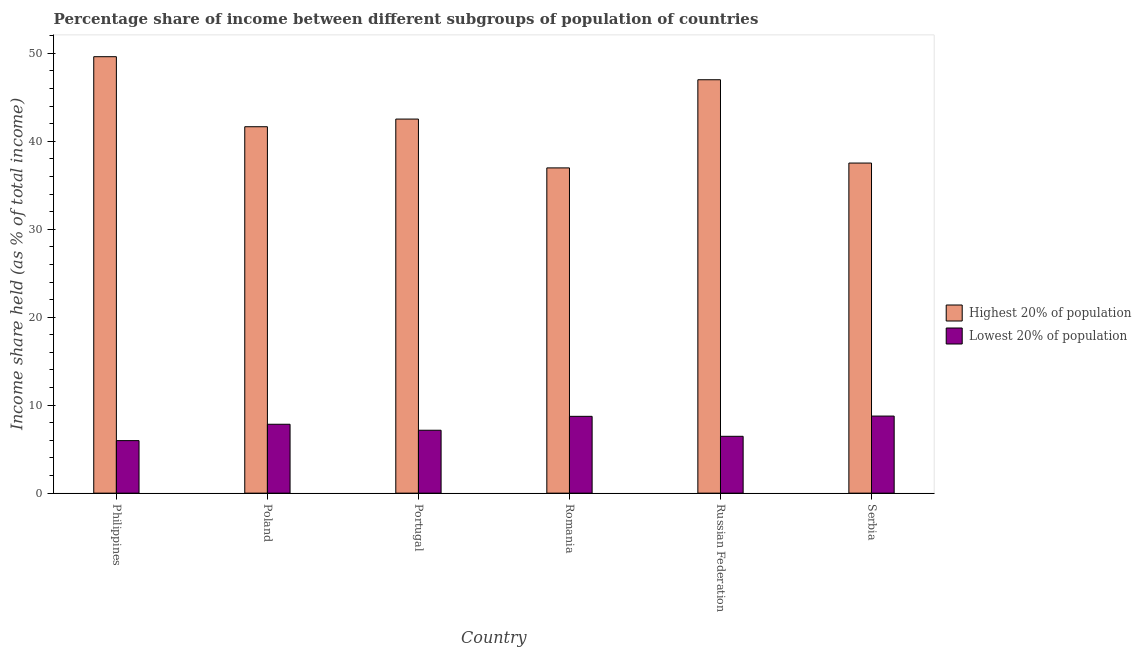How many different coloured bars are there?
Keep it short and to the point. 2. How many groups of bars are there?
Your answer should be compact. 6. Are the number of bars on each tick of the X-axis equal?
Your answer should be very brief. Yes. How many bars are there on the 4th tick from the left?
Give a very brief answer. 2. What is the label of the 1st group of bars from the left?
Provide a short and direct response. Philippines. In how many cases, is the number of bars for a given country not equal to the number of legend labels?
Your answer should be compact. 0. What is the income share held by lowest 20% of the population in Poland?
Offer a terse response. 7.83. Across all countries, what is the maximum income share held by lowest 20% of the population?
Give a very brief answer. 8.76. Across all countries, what is the minimum income share held by highest 20% of the population?
Keep it short and to the point. 36.97. In which country was the income share held by highest 20% of the population minimum?
Offer a terse response. Romania. What is the total income share held by lowest 20% of the population in the graph?
Make the answer very short. 44.9. What is the difference between the income share held by lowest 20% of the population in Philippines and that in Russian Federation?
Give a very brief answer. -0.49. What is the difference between the income share held by lowest 20% of the population in Philippines and the income share held by highest 20% of the population in Romania?
Offer a very short reply. -31. What is the average income share held by highest 20% of the population per country?
Make the answer very short. 42.54. What is the difference between the income share held by highest 20% of the population and income share held by lowest 20% of the population in Portugal?
Give a very brief answer. 35.37. In how many countries, is the income share held by highest 20% of the population greater than 48 %?
Provide a short and direct response. 1. What is the ratio of the income share held by highest 20% of the population in Russian Federation to that in Serbia?
Your answer should be compact. 1.25. What is the difference between the highest and the second highest income share held by highest 20% of the population?
Your response must be concise. 2.62. What is the difference between the highest and the lowest income share held by lowest 20% of the population?
Provide a short and direct response. 2.79. In how many countries, is the income share held by lowest 20% of the population greater than the average income share held by lowest 20% of the population taken over all countries?
Provide a succinct answer. 3. Is the sum of the income share held by highest 20% of the population in Philippines and Russian Federation greater than the maximum income share held by lowest 20% of the population across all countries?
Your answer should be very brief. Yes. What does the 2nd bar from the left in Russian Federation represents?
Provide a short and direct response. Lowest 20% of population. What does the 2nd bar from the right in Russian Federation represents?
Make the answer very short. Highest 20% of population. How many countries are there in the graph?
Your answer should be very brief. 6. How many legend labels are there?
Keep it short and to the point. 2. What is the title of the graph?
Offer a terse response. Percentage share of income between different subgroups of population of countries. Does "Non-resident workers" appear as one of the legend labels in the graph?
Keep it short and to the point. No. What is the label or title of the Y-axis?
Keep it short and to the point. Income share held (as % of total income). What is the Income share held (as % of total income) in Highest 20% of population in Philippines?
Keep it short and to the point. 49.61. What is the Income share held (as % of total income) in Lowest 20% of population in Philippines?
Your answer should be very brief. 5.97. What is the Income share held (as % of total income) in Highest 20% of population in Poland?
Your answer should be very brief. 41.65. What is the Income share held (as % of total income) in Lowest 20% of population in Poland?
Ensure brevity in your answer.  7.83. What is the Income share held (as % of total income) of Highest 20% of population in Portugal?
Your answer should be compact. 42.52. What is the Income share held (as % of total income) of Lowest 20% of population in Portugal?
Your answer should be very brief. 7.15. What is the Income share held (as % of total income) in Highest 20% of population in Romania?
Make the answer very short. 36.97. What is the Income share held (as % of total income) of Lowest 20% of population in Romania?
Keep it short and to the point. 8.73. What is the Income share held (as % of total income) of Highest 20% of population in Russian Federation?
Offer a very short reply. 46.99. What is the Income share held (as % of total income) in Lowest 20% of population in Russian Federation?
Your answer should be very brief. 6.46. What is the Income share held (as % of total income) in Highest 20% of population in Serbia?
Give a very brief answer. 37.52. What is the Income share held (as % of total income) of Lowest 20% of population in Serbia?
Keep it short and to the point. 8.76. Across all countries, what is the maximum Income share held (as % of total income) of Highest 20% of population?
Make the answer very short. 49.61. Across all countries, what is the maximum Income share held (as % of total income) in Lowest 20% of population?
Keep it short and to the point. 8.76. Across all countries, what is the minimum Income share held (as % of total income) of Highest 20% of population?
Offer a very short reply. 36.97. Across all countries, what is the minimum Income share held (as % of total income) of Lowest 20% of population?
Your answer should be compact. 5.97. What is the total Income share held (as % of total income) of Highest 20% of population in the graph?
Your response must be concise. 255.26. What is the total Income share held (as % of total income) in Lowest 20% of population in the graph?
Give a very brief answer. 44.9. What is the difference between the Income share held (as % of total income) in Highest 20% of population in Philippines and that in Poland?
Your answer should be very brief. 7.96. What is the difference between the Income share held (as % of total income) of Lowest 20% of population in Philippines and that in Poland?
Offer a very short reply. -1.86. What is the difference between the Income share held (as % of total income) in Highest 20% of population in Philippines and that in Portugal?
Keep it short and to the point. 7.09. What is the difference between the Income share held (as % of total income) in Lowest 20% of population in Philippines and that in Portugal?
Your answer should be compact. -1.18. What is the difference between the Income share held (as % of total income) in Highest 20% of population in Philippines and that in Romania?
Ensure brevity in your answer.  12.64. What is the difference between the Income share held (as % of total income) in Lowest 20% of population in Philippines and that in Romania?
Provide a succinct answer. -2.76. What is the difference between the Income share held (as % of total income) in Highest 20% of population in Philippines and that in Russian Federation?
Give a very brief answer. 2.62. What is the difference between the Income share held (as % of total income) in Lowest 20% of population in Philippines and that in Russian Federation?
Your response must be concise. -0.49. What is the difference between the Income share held (as % of total income) in Highest 20% of population in Philippines and that in Serbia?
Give a very brief answer. 12.09. What is the difference between the Income share held (as % of total income) in Lowest 20% of population in Philippines and that in Serbia?
Give a very brief answer. -2.79. What is the difference between the Income share held (as % of total income) of Highest 20% of population in Poland and that in Portugal?
Offer a terse response. -0.87. What is the difference between the Income share held (as % of total income) of Lowest 20% of population in Poland and that in Portugal?
Your response must be concise. 0.68. What is the difference between the Income share held (as % of total income) of Highest 20% of population in Poland and that in Romania?
Offer a very short reply. 4.68. What is the difference between the Income share held (as % of total income) of Highest 20% of population in Poland and that in Russian Federation?
Your answer should be very brief. -5.34. What is the difference between the Income share held (as % of total income) of Lowest 20% of population in Poland and that in Russian Federation?
Offer a terse response. 1.37. What is the difference between the Income share held (as % of total income) in Highest 20% of population in Poland and that in Serbia?
Keep it short and to the point. 4.13. What is the difference between the Income share held (as % of total income) of Lowest 20% of population in Poland and that in Serbia?
Provide a short and direct response. -0.93. What is the difference between the Income share held (as % of total income) in Highest 20% of population in Portugal and that in Romania?
Make the answer very short. 5.55. What is the difference between the Income share held (as % of total income) in Lowest 20% of population in Portugal and that in Romania?
Provide a short and direct response. -1.58. What is the difference between the Income share held (as % of total income) in Highest 20% of population in Portugal and that in Russian Federation?
Ensure brevity in your answer.  -4.47. What is the difference between the Income share held (as % of total income) of Lowest 20% of population in Portugal and that in Russian Federation?
Offer a terse response. 0.69. What is the difference between the Income share held (as % of total income) in Lowest 20% of population in Portugal and that in Serbia?
Provide a succinct answer. -1.61. What is the difference between the Income share held (as % of total income) in Highest 20% of population in Romania and that in Russian Federation?
Your answer should be compact. -10.02. What is the difference between the Income share held (as % of total income) of Lowest 20% of population in Romania and that in Russian Federation?
Your answer should be very brief. 2.27. What is the difference between the Income share held (as % of total income) in Highest 20% of population in Romania and that in Serbia?
Provide a succinct answer. -0.55. What is the difference between the Income share held (as % of total income) of Lowest 20% of population in Romania and that in Serbia?
Give a very brief answer. -0.03. What is the difference between the Income share held (as % of total income) in Highest 20% of population in Russian Federation and that in Serbia?
Provide a short and direct response. 9.47. What is the difference between the Income share held (as % of total income) in Lowest 20% of population in Russian Federation and that in Serbia?
Your answer should be very brief. -2.3. What is the difference between the Income share held (as % of total income) of Highest 20% of population in Philippines and the Income share held (as % of total income) of Lowest 20% of population in Poland?
Your response must be concise. 41.78. What is the difference between the Income share held (as % of total income) in Highest 20% of population in Philippines and the Income share held (as % of total income) in Lowest 20% of population in Portugal?
Provide a short and direct response. 42.46. What is the difference between the Income share held (as % of total income) of Highest 20% of population in Philippines and the Income share held (as % of total income) of Lowest 20% of population in Romania?
Offer a terse response. 40.88. What is the difference between the Income share held (as % of total income) in Highest 20% of population in Philippines and the Income share held (as % of total income) in Lowest 20% of population in Russian Federation?
Ensure brevity in your answer.  43.15. What is the difference between the Income share held (as % of total income) of Highest 20% of population in Philippines and the Income share held (as % of total income) of Lowest 20% of population in Serbia?
Provide a succinct answer. 40.85. What is the difference between the Income share held (as % of total income) in Highest 20% of population in Poland and the Income share held (as % of total income) in Lowest 20% of population in Portugal?
Keep it short and to the point. 34.5. What is the difference between the Income share held (as % of total income) in Highest 20% of population in Poland and the Income share held (as % of total income) in Lowest 20% of population in Romania?
Ensure brevity in your answer.  32.92. What is the difference between the Income share held (as % of total income) in Highest 20% of population in Poland and the Income share held (as % of total income) in Lowest 20% of population in Russian Federation?
Your answer should be very brief. 35.19. What is the difference between the Income share held (as % of total income) of Highest 20% of population in Poland and the Income share held (as % of total income) of Lowest 20% of population in Serbia?
Your answer should be compact. 32.89. What is the difference between the Income share held (as % of total income) of Highest 20% of population in Portugal and the Income share held (as % of total income) of Lowest 20% of population in Romania?
Your answer should be very brief. 33.79. What is the difference between the Income share held (as % of total income) in Highest 20% of population in Portugal and the Income share held (as % of total income) in Lowest 20% of population in Russian Federation?
Your response must be concise. 36.06. What is the difference between the Income share held (as % of total income) of Highest 20% of population in Portugal and the Income share held (as % of total income) of Lowest 20% of population in Serbia?
Offer a very short reply. 33.76. What is the difference between the Income share held (as % of total income) in Highest 20% of population in Romania and the Income share held (as % of total income) in Lowest 20% of population in Russian Federation?
Offer a very short reply. 30.51. What is the difference between the Income share held (as % of total income) of Highest 20% of population in Romania and the Income share held (as % of total income) of Lowest 20% of population in Serbia?
Give a very brief answer. 28.21. What is the difference between the Income share held (as % of total income) of Highest 20% of population in Russian Federation and the Income share held (as % of total income) of Lowest 20% of population in Serbia?
Provide a succinct answer. 38.23. What is the average Income share held (as % of total income) in Highest 20% of population per country?
Your answer should be compact. 42.54. What is the average Income share held (as % of total income) in Lowest 20% of population per country?
Your answer should be very brief. 7.48. What is the difference between the Income share held (as % of total income) of Highest 20% of population and Income share held (as % of total income) of Lowest 20% of population in Philippines?
Offer a terse response. 43.64. What is the difference between the Income share held (as % of total income) in Highest 20% of population and Income share held (as % of total income) in Lowest 20% of population in Poland?
Offer a very short reply. 33.82. What is the difference between the Income share held (as % of total income) in Highest 20% of population and Income share held (as % of total income) in Lowest 20% of population in Portugal?
Give a very brief answer. 35.37. What is the difference between the Income share held (as % of total income) in Highest 20% of population and Income share held (as % of total income) in Lowest 20% of population in Romania?
Keep it short and to the point. 28.24. What is the difference between the Income share held (as % of total income) in Highest 20% of population and Income share held (as % of total income) in Lowest 20% of population in Russian Federation?
Your answer should be very brief. 40.53. What is the difference between the Income share held (as % of total income) of Highest 20% of population and Income share held (as % of total income) of Lowest 20% of population in Serbia?
Keep it short and to the point. 28.76. What is the ratio of the Income share held (as % of total income) in Highest 20% of population in Philippines to that in Poland?
Offer a terse response. 1.19. What is the ratio of the Income share held (as % of total income) of Lowest 20% of population in Philippines to that in Poland?
Make the answer very short. 0.76. What is the ratio of the Income share held (as % of total income) of Highest 20% of population in Philippines to that in Portugal?
Ensure brevity in your answer.  1.17. What is the ratio of the Income share held (as % of total income) in Lowest 20% of population in Philippines to that in Portugal?
Offer a terse response. 0.83. What is the ratio of the Income share held (as % of total income) of Highest 20% of population in Philippines to that in Romania?
Your answer should be compact. 1.34. What is the ratio of the Income share held (as % of total income) of Lowest 20% of population in Philippines to that in Romania?
Your answer should be compact. 0.68. What is the ratio of the Income share held (as % of total income) of Highest 20% of population in Philippines to that in Russian Federation?
Ensure brevity in your answer.  1.06. What is the ratio of the Income share held (as % of total income) in Lowest 20% of population in Philippines to that in Russian Federation?
Give a very brief answer. 0.92. What is the ratio of the Income share held (as % of total income) of Highest 20% of population in Philippines to that in Serbia?
Provide a succinct answer. 1.32. What is the ratio of the Income share held (as % of total income) of Lowest 20% of population in Philippines to that in Serbia?
Provide a succinct answer. 0.68. What is the ratio of the Income share held (as % of total income) of Highest 20% of population in Poland to that in Portugal?
Your response must be concise. 0.98. What is the ratio of the Income share held (as % of total income) of Lowest 20% of population in Poland to that in Portugal?
Keep it short and to the point. 1.1. What is the ratio of the Income share held (as % of total income) in Highest 20% of population in Poland to that in Romania?
Your response must be concise. 1.13. What is the ratio of the Income share held (as % of total income) in Lowest 20% of population in Poland to that in Romania?
Give a very brief answer. 0.9. What is the ratio of the Income share held (as % of total income) in Highest 20% of population in Poland to that in Russian Federation?
Offer a terse response. 0.89. What is the ratio of the Income share held (as % of total income) of Lowest 20% of population in Poland to that in Russian Federation?
Your response must be concise. 1.21. What is the ratio of the Income share held (as % of total income) of Highest 20% of population in Poland to that in Serbia?
Give a very brief answer. 1.11. What is the ratio of the Income share held (as % of total income) of Lowest 20% of population in Poland to that in Serbia?
Offer a very short reply. 0.89. What is the ratio of the Income share held (as % of total income) in Highest 20% of population in Portugal to that in Romania?
Your answer should be very brief. 1.15. What is the ratio of the Income share held (as % of total income) of Lowest 20% of population in Portugal to that in Romania?
Provide a short and direct response. 0.82. What is the ratio of the Income share held (as % of total income) in Highest 20% of population in Portugal to that in Russian Federation?
Your answer should be very brief. 0.9. What is the ratio of the Income share held (as % of total income) in Lowest 20% of population in Portugal to that in Russian Federation?
Keep it short and to the point. 1.11. What is the ratio of the Income share held (as % of total income) of Highest 20% of population in Portugal to that in Serbia?
Make the answer very short. 1.13. What is the ratio of the Income share held (as % of total income) in Lowest 20% of population in Portugal to that in Serbia?
Give a very brief answer. 0.82. What is the ratio of the Income share held (as % of total income) in Highest 20% of population in Romania to that in Russian Federation?
Ensure brevity in your answer.  0.79. What is the ratio of the Income share held (as % of total income) of Lowest 20% of population in Romania to that in Russian Federation?
Offer a very short reply. 1.35. What is the ratio of the Income share held (as % of total income) of Highest 20% of population in Romania to that in Serbia?
Your answer should be compact. 0.99. What is the ratio of the Income share held (as % of total income) of Lowest 20% of population in Romania to that in Serbia?
Your response must be concise. 1. What is the ratio of the Income share held (as % of total income) of Highest 20% of population in Russian Federation to that in Serbia?
Give a very brief answer. 1.25. What is the ratio of the Income share held (as % of total income) of Lowest 20% of population in Russian Federation to that in Serbia?
Provide a succinct answer. 0.74. What is the difference between the highest and the second highest Income share held (as % of total income) in Highest 20% of population?
Ensure brevity in your answer.  2.62. What is the difference between the highest and the second highest Income share held (as % of total income) in Lowest 20% of population?
Provide a succinct answer. 0.03. What is the difference between the highest and the lowest Income share held (as % of total income) of Highest 20% of population?
Provide a short and direct response. 12.64. What is the difference between the highest and the lowest Income share held (as % of total income) in Lowest 20% of population?
Provide a short and direct response. 2.79. 